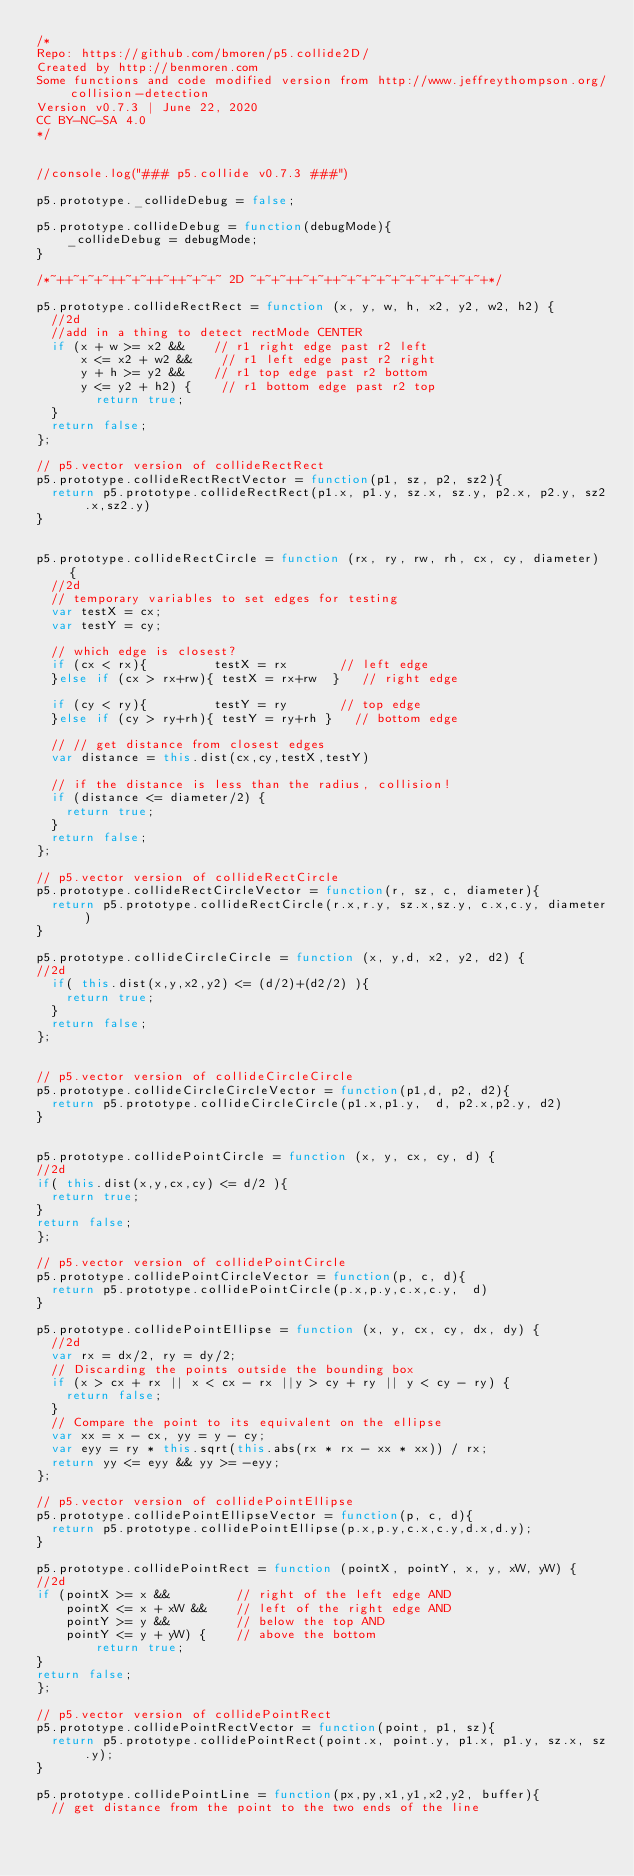Convert code to text. <code><loc_0><loc_0><loc_500><loc_500><_JavaScript_>/*
Repo: https://github.com/bmoren/p5.collide2D/
Created by http://benmoren.com
Some functions and code modified version from http://www.jeffreythompson.org/collision-detection
Version v0.7.3 | June 22, 2020
CC BY-NC-SA 4.0
*/


//console.log("### p5.collide v0.7.3 ###")

p5.prototype._collideDebug = false;

p5.prototype.collideDebug = function(debugMode){
    _collideDebug = debugMode;
}

/*~++~+~+~++~+~++~++~+~+~ 2D ~+~+~++~+~++~+~+~+~+~+~+~+~+~+~+*/

p5.prototype.collideRectRect = function (x, y, w, h, x2, y2, w2, h2) {
  //2d
  //add in a thing to detect rectMode CENTER
  if (x + w >= x2 &&    // r1 right edge past r2 left
      x <= x2 + w2 &&    // r1 left edge past r2 right
      y + h >= y2 &&    // r1 top edge past r2 bottom
      y <= y2 + h2) {    // r1 bottom edge past r2 top
        return true;
  }
  return false;
};

// p5.vector version of collideRectRect
p5.prototype.collideRectRectVector = function(p1, sz, p2, sz2){
  return p5.prototype.collideRectRect(p1.x, p1.y, sz.x, sz.y, p2.x, p2.y, sz2.x,sz2.y)
}


p5.prototype.collideRectCircle = function (rx, ry, rw, rh, cx, cy, diameter) {
  //2d
  // temporary variables to set edges for testing
  var testX = cx;
  var testY = cy;

  // which edge is closest?
  if (cx < rx){         testX = rx       // left edge
  }else if (cx > rx+rw){ testX = rx+rw  }   // right edge

  if (cy < ry){         testY = ry       // top edge
  }else if (cy > ry+rh){ testY = ry+rh }   // bottom edge

  // // get distance from closest edges
  var distance = this.dist(cx,cy,testX,testY)

  // if the distance is less than the radius, collision!
  if (distance <= diameter/2) {
    return true;
  }
  return false;
};

// p5.vector version of collideRectCircle
p5.prototype.collideRectCircleVector = function(r, sz, c, diameter){
  return p5.prototype.collideRectCircle(r.x,r.y, sz.x,sz.y, c.x,c.y, diameter)
}

p5.prototype.collideCircleCircle = function (x, y,d, x2, y2, d2) {
//2d
  if( this.dist(x,y,x2,y2) <= (d/2)+(d2/2) ){
    return true;
  }
  return false;
};


// p5.vector version of collideCircleCircle
p5.prototype.collideCircleCircleVector = function(p1,d, p2, d2){
  return p5.prototype.collideCircleCircle(p1.x,p1.y,  d, p2.x,p2.y, d2)
}


p5.prototype.collidePointCircle = function (x, y, cx, cy, d) {
//2d
if( this.dist(x,y,cx,cy) <= d/2 ){
  return true;
}
return false;
};

// p5.vector version of collidePointCircle
p5.prototype.collidePointCircleVector = function(p, c, d){
  return p5.prototype.collidePointCircle(p.x,p.y,c.x,c.y,  d)
}

p5.prototype.collidePointEllipse = function (x, y, cx, cy, dx, dy) {
  //2d
  var rx = dx/2, ry = dy/2;
  // Discarding the points outside the bounding box
  if (x > cx + rx || x < cx - rx ||y > cy + ry || y < cy - ry) {
		return false;
  }
  // Compare the point to its equivalent on the ellipse
  var xx = x - cx, yy = y - cy;
  var eyy = ry * this.sqrt(this.abs(rx * rx - xx * xx)) / rx;
  return yy <= eyy && yy >= -eyy;
};

// p5.vector version of collidePointEllipse
p5.prototype.collidePointEllipseVector = function(p, c, d){
  return p5.prototype.collidePointEllipse(p.x,p.y,c.x,c.y,d.x,d.y);
}

p5.prototype.collidePointRect = function (pointX, pointY, x, y, xW, yW) {
//2d
if (pointX >= x &&         // right of the left edge AND
    pointX <= x + xW &&    // left of the right edge AND
    pointY >= y &&         // below the top AND
    pointY <= y + yW) {    // above the bottom
        return true;
}
return false;
};

// p5.vector version of collidePointRect
p5.prototype.collidePointRectVector = function(point, p1, sz){
  return p5.prototype.collidePointRect(point.x, point.y, p1.x, p1.y, sz.x, sz.y);
}

p5.prototype.collidePointLine = function(px,py,x1,y1,x2,y2, buffer){
  // get distance from the point to the two ends of the line</code> 